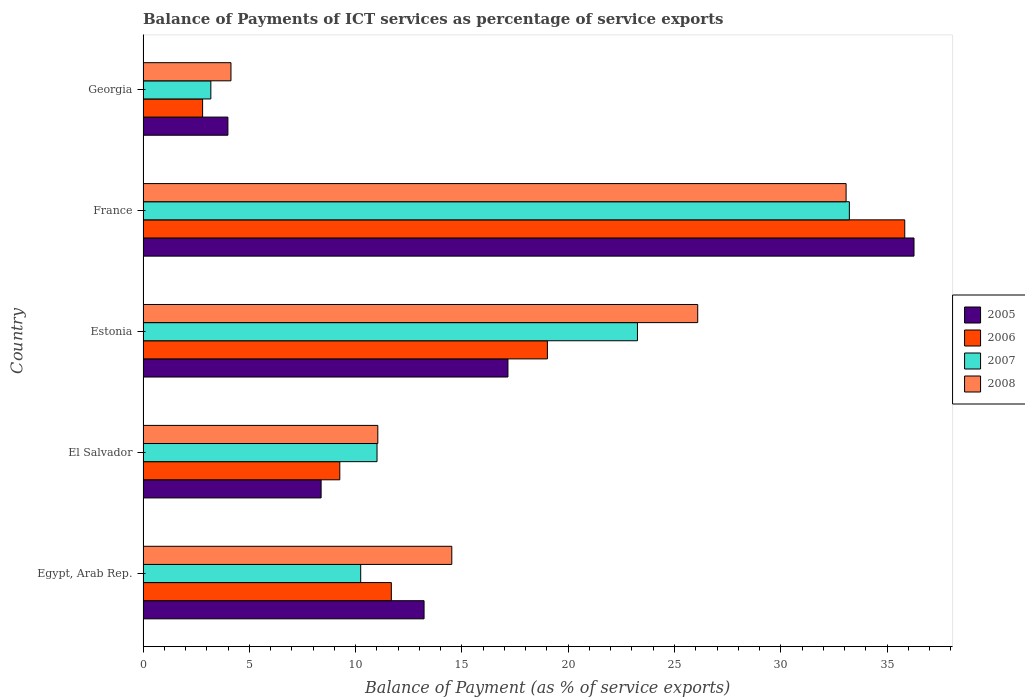Are the number of bars per tick equal to the number of legend labels?
Your answer should be very brief. Yes. How many bars are there on the 2nd tick from the top?
Your answer should be compact. 4. How many bars are there on the 1st tick from the bottom?
Your response must be concise. 4. What is the label of the 3rd group of bars from the top?
Provide a short and direct response. Estonia. In how many cases, is the number of bars for a given country not equal to the number of legend labels?
Your answer should be very brief. 0. What is the balance of payments of ICT services in 2006 in Georgia?
Your answer should be very brief. 2.8. Across all countries, what is the maximum balance of payments of ICT services in 2007?
Provide a succinct answer. 33.23. Across all countries, what is the minimum balance of payments of ICT services in 2008?
Offer a terse response. 4.14. In which country was the balance of payments of ICT services in 2007 minimum?
Keep it short and to the point. Georgia. What is the total balance of payments of ICT services in 2005 in the graph?
Provide a succinct answer. 79.02. What is the difference between the balance of payments of ICT services in 2008 in Egypt, Arab Rep. and that in France?
Ensure brevity in your answer.  -18.55. What is the difference between the balance of payments of ICT services in 2005 in France and the balance of payments of ICT services in 2008 in El Salvador?
Provide a short and direct response. 25.22. What is the average balance of payments of ICT services in 2008 per country?
Your response must be concise. 17.77. What is the difference between the balance of payments of ICT services in 2007 and balance of payments of ICT services in 2006 in Estonia?
Your answer should be compact. 4.24. In how many countries, is the balance of payments of ICT services in 2007 greater than 26 %?
Your answer should be very brief. 1. What is the ratio of the balance of payments of ICT services in 2006 in Estonia to that in France?
Give a very brief answer. 0.53. Is the balance of payments of ICT services in 2008 in Estonia less than that in Georgia?
Offer a terse response. No. What is the difference between the highest and the second highest balance of payments of ICT services in 2007?
Give a very brief answer. 9.97. What is the difference between the highest and the lowest balance of payments of ICT services in 2008?
Keep it short and to the point. 28.94. In how many countries, is the balance of payments of ICT services in 2005 greater than the average balance of payments of ICT services in 2005 taken over all countries?
Your answer should be very brief. 2. What does the 4th bar from the bottom in El Salvador represents?
Give a very brief answer. 2008. Is it the case that in every country, the sum of the balance of payments of ICT services in 2008 and balance of payments of ICT services in 2006 is greater than the balance of payments of ICT services in 2007?
Your response must be concise. Yes. How many bars are there?
Your response must be concise. 20. Are all the bars in the graph horizontal?
Ensure brevity in your answer.  Yes. How many countries are there in the graph?
Keep it short and to the point. 5. What is the difference between two consecutive major ticks on the X-axis?
Give a very brief answer. 5. Does the graph contain any zero values?
Keep it short and to the point. No. Does the graph contain grids?
Keep it short and to the point. No. How many legend labels are there?
Provide a succinct answer. 4. How are the legend labels stacked?
Your response must be concise. Vertical. What is the title of the graph?
Your response must be concise. Balance of Payments of ICT services as percentage of service exports. What is the label or title of the X-axis?
Offer a terse response. Balance of Payment (as % of service exports). What is the label or title of the Y-axis?
Your response must be concise. Country. What is the Balance of Payment (as % of service exports) in 2005 in Egypt, Arab Rep.?
Your response must be concise. 13.22. What is the Balance of Payment (as % of service exports) in 2006 in Egypt, Arab Rep.?
Give a very brief answer. 11.68. What is the Balance of Payment (as % of service exports) in 2007 in Egypt, Arab Rep.?
Your answer should be compact. 10.24. What is the Balance of Payment (as % of service exports) in 2008 in Egypt, Arab Rep.?
Make the answer very short. 14.52. What is the Balance of Payment (as % of service exports) of 2005 in El Salvador?
Provide a succinct answer. 8.38. What is the Balance of Payment (as % of service exports) in 2006 in El Salvador?
Your answer should be compact. 9.25. What is the Balance of Payment (as % of service exports) of 2007 in El Salvador?
Your response must be concise. 11.01. What is the Balance of Payment (as % of service exports) of 2008 in El Salvador?
Make the answer very short. 11.04. What is the Balance of Payment (as % of service exports) of 2005 in Estonia?
Offer a terse response. 17.16. What is the Balance of Payment (as % of service exports) of 2006 in Estonia?
Make the answer very short. 19.02. What is the Balance of Payment (as % of service exports) of 2007 in Estonia?
Your answer should be compact. 23.26. What is the Balance of Payment (as % of service exports) of 2008 in Estonia?
Give a very brief answer. 26.09. What is the Balance of Payment (as % of service exports) in 2005 in France?
Make the answer very short. 36.27. What is the Balance of Payment (as % of service exports) of 2006 in France?
Ensure brevity in your answer.  35.83. What is the Balance of Payment (as % of service exports) in 2007 in France?
Your answer should be compact. 33.23. What is the Balance of Payment (as % of service exports) of 2008 in France?
Your answer should be compact. 33.07. What is the Balance of Payment (as % of service exports) in 2005 in Georgia?
Offer a terse response. 3.99. What is the Balance of Payment (as % of service exports) in 2006 in Georgia?
Your response must be concise. 2.8. What is the Balance of Payment (as % of service exports) in 2007 in Georgia?
Your answer should be very brief. 3.19. What is the Balance of Payment (as % of service exports) of 2008 in Georgia?
Offer a terse response. 4.14. Across all countries, what is the maximum Balance of Payment (as % of service exports) of 2005?
Your answer should be very brief. 36.27. Across all countries, what is the maximum Balance of Payment (as % of service exports) of 2006?
Keep it short and to the point. 35.83. Across all countries, what is the maximum Balance of Payment (as % of service exports) in 2007?
Your response must be concise. 33.23. Across all countries, what is the maximum Balance of Payment (as % of service exports) in 2008?
Provide a short and direct response. 33.07. Across all countries, what is the minimum Balance of Payment (as % of service exports) in 2005?
Make the answer very short. 3.99. Across all countries, what is the minimum Balance of Payment (as % of service exports) of 2006?
Provide a succinct answer. 2.8. Across all countries, what is the minimum Balance of Payment (as % of service exports) in 2007?
Make the answer very short. 3.19. Across all countries, what is the minimum Balance of Payment (as % of service exports) of 2008?
Your response must be concise. 4.14. What is the total Balance of Payment (as % of service exports) of 2005 in the graph?
Your answer should be compact. 79.02. What is the total Balance of Payment (as % of service exports) in 2006 in the graph?
Provide a succinct answer. 78.59. What is the total Balance of Payment (as % of service exports) of 2007 in the graph?
Your response must be concise. 80.92. What is the total Balance of Payment (as % of service exports) of 2008 in the graph?
Offer a very short reply. 88.87. What is the difference between the Balance of Payment (as % of service exports) in 2005 in Egypt, Arab Rep. and that in El Salvador?
Your response must be concise. 4.84. What is the difference between the Balance of Payment (as % of service exports) in 2006 in Egypt, Arab Rep. and that in El Salvador?
Make the answer very short. 2.43. What is the difference between the Balance of Payment (as % of service exports) in 2007 in Egypt, Arab Rep. and that in El Salvador?
Provide a succinct answer. -0.77. What is the difference between the Balance of Payment (as % of service exports) in 2008 in Egypt, Arab Rep. and that in El Salvador?
Your response must be concise. 3.48. What is the difference between the Balance of Payment (as % of service exports) in 2005 in Egypt, Arab Rep. and that in Estonia?
Offer a terse response. -3.95. What is the difference between the Balance of Payment (as % of service exports) of 2006 in Egypt, Arab Rep. and that in Estonia?
Your answer should be very brief. -7.34. What is the difference between the Balance of Payment (as % of service exports) in 2007 in Egypt, Arab Rep. and that in Estonia?
Provide a succinct answer. -13.02. What is the difference between the Balance of Payment (as % of service exports) in 2008 in Egypt, Arab Rep. and that in Estonia?
Keep it short and to the point. -11.57. What is the difference between the Balance of Payment (as % of service exports) in 2005 in Egypt, Arab Rep. and that in France?
Provide a short and direct response. -23.05. What is the difference between the Balance of Payment (as % of service exports) in 2006 in Egypt, Arab Rep. and that in France?
Your answer should be very brief. -24.15. What is the difference between the Balance of Payment (as % of service exports) of 2007 in Egypt, Arab Rep. and that in France?
Your answer should be very brief. -22.99. What is the difference between the Balance of Payment (as % of service exports) in 2008 in Egypt, Arab Rep. and that in France?
Make the answer very short. -18.55. What is the difference between the Balance of Payment (as % of service exports) in 2005 in Egypt, Arab Rep. and that in Georgia?
Keep it short and to the point. 9.23. What is the difference between the Balance of Payment (as % of service exports) of 2006 in Egypt, Arab Rep. and that in Georgia?
Provide a short and direct response. 8.88. What is the difference between the Balance of Payment (as % of service exports) in 2007 in Egypt, Arab Rep. and that in Georgia?
Provide a short and direct response. 7.05. What is the difference between the Balance of Payment (as % of service exports) in 2008 in Egypt, Arab Rep. and that in Georgia?
Make the answer very short. 10.39. What is the difference between the Balance of Payment (as % of service exports) of 2005 in El Salvador and that in Estonia?
Provide a short and direct response. -8.79. What is the difference between the Balance of Payment (as % of service exports) of 2006 in El Salvador and that in Estonia?
Keep it short and to the point. -9.77. What is the difference between the Balance of Payment (as % of service exports) in 2007 in El Salvador and that in Estonia?
Give a very brief answer. -12.25. What is the difference between the Balance of Payment (as % of service exports) in 2008 in El Salvador and that in Estonia?
Your answer should be compact. -15.05. What is the difference between the Balance of Payment (as % of service exports) in 2005 in El Salvador and that in France?
Offer a very short reply. -27.89. What is the difference between the Balance of Payment (as % of service exports) in 2006 in El Salvador and that in France?
Your answer should be compact. -26.58. What is the difference between the Balance of Payment (as % of service exports) of 2007 in El Salvador and that in France?
Your answer should be compact. -22.22. What is the difference between the Balance of Payment (as % of service exports) of 2008 in El Salvador and that in France?
Provide a succinct answer. -22.03. What is the difference between the Balance of Payment (as % of service exports) in 2005 in El Salvador and that in Georgia?
Provide a short and direct response. 4.38. What is the difference between the Balance of Payment (as % of service exports) of 2006 in El Salvador and that in Georgia?
Provide a succinct answer. 6.45. What is the difference between the Balance of Payment (as % of service exports) in 2007 in El Salvador and that in Georgia?
Make the answer very short. 7.82. What is the difference between the Balance of Payment (as % of service exports) in 2008 in El Salvador and that in Georgia?
Make the answer very short. 6.91. What is the difference between the Balance of Payment (as % of service exports) in 2005 in Estonia and that in France?
Offer a very short reply. -19.1. What is the difference between the Balance of Payment (as % of service exports) of 2006 in Estonia and that in France?
Ensure brevity in your answer.  -16.81. What is the difference between the Balance of Payment (as % of service exports) in 2007 in Estonia and that in France?
Provide a short and direct response. -9.97. What is the difference between the Balance of Payment (as % of service exports) in 2008 in Estonia and that in France?
Provide a short and direct response. -6.98. What is the difference between the Balance of Payment (as % of service exports) in 2005 in Estonia and that in Georgia?
Offer a very short reply. 13.17. What is the difference between the Balance of Payment (as % of service exports) of 2006 in Estonia and that in Georgia?
Offer a very short reply. 16.22. What is the difference between the Balance of Payment (as % of service exports) of 2007 in Estonia and that in Georgia?
Make the answer very short. 20.07. What is the difference between the Balance of Payment (as % of service exports) of 2008 in Estonia and that in Georgia?
Your answer should be very brief. 21.96. What is the difference between the Balance of Payment (as % of service exports) in 2005 in France and that in Georgia?
Your answer should be compact. 32.28. What is the difference between the Balance of Payment (as % of service exports) of 2006 in France and that in Georgia?
Provide a succinct answer. 33.03. What is the difference between the Balance of Payment (as % of service exports) in 2007 in France and that in Georgia?
Keep it short and to the point. 30.04. What is the difference between the Balance of Payment (as % of service exports) of 2008 in France and that in Georgia?
Ensure brevity in your answer.  28.94. What is the difference between the Balance of Payment (as % of service exports) of 2005 in Egypt, Arab Rep. and the Balance of Payment (as % of service exports) of 2006 in El Salvador?
Keep it short and to the point. 3.96. What is the difference between the Balance of Payment (as % of service exports) of 2005 in Egypt, Arab Rep. and the Balance of Payment (as % of service exports) of 2007 in El Salvador?
Give a very brief answer. 2.21. What is the difference between the Balance of Payment (as % of service exports) of 2005 in Egypt, Arab Rep. and the Balance of Payment (as % of service exports) of 2008 in El Salvador?
Your response must be concise. 2.18. What is the difference between the Balance of Payment (as % of service exports) in 2006 in Egypt, Arab Rep. and the Balance of Payment (as % of service exports) in 2007 in El Salvador?
Offer a very short reply. 0.67. What is the difference between the Balance of Payment (as % of service exports) in 2006 in Egypt, Arab Rep. and the Balance of Payment (as % of service exports) in 2008 in El Salvador?
Your response must be concise. 0.64. What is the difference between the Balance of Payment (as % of service exports) in 2007 in Egypt, Arab Rep. and the Balance of Payment (as % of service exports) in 2008 in El Salvador?
Your answer should be very brief. -0.8. What is the difference between the Balance of Payment (as % of service exports) of 2005 in Egypt, Arab Rep. and the Balance of Payment (as % of service exports) of 2006 in Estonia?
Your answer should be compact. -5.8. What is the difference between the Balance of Payment (as % of service exports) of 2005 in Egypt, Arab Rep. and the Balance of Payment (as % of service exports) of 2007 in Estonia?
Your answer should be very brief. -10.04. What is the difference between the Balance of Payment (as % of service exports) in 2005 in Egypt, Arab Rep. and the Balance of Payment (as % of service exports) in 2008 in Estonia?
Provide a short and direct response. -12.87. What is the difference between the Balance of Payment (as % of service exports) in 2006 in Egypt, Arab Rep. and the Balance of Payment (as % of service exports) in 2007 in Estonia?
Give a very brief answer. -11.58. What is the difference between the Balance of Payment (as % of service exports) of 2006 in Egypt, Arab Rep. and the Balance of Payment (as % of service exports) of 2008 in Estonia?
Your answer should be very brief. -14.41. What is the difference between the Balance of Payment (as % of service exports) in 2007 in Egypt, Arab Rep. and the Balance of Payment (as % of service exports) in 2008 in Estonia?
Your answer should be very brief. -15.85. What is the difference between the Balance of Payment (as % of service exports) of 2005 in Egypt, Arab Rep. and the Balance of Payment (as % of service exports) of 2006 in France?
Offer a terse response. -22.61. What is the difference between the Balance of Payment (as % of service exports) in 2005 in Egypt, Arab Rep. and the Balance of Payment (as % of service exports) in 2007 in France?
Your response must be concise. -20.01. What is the difference between the Balance of Payment (as % of service exports) of 2005 in Egypt, Arab Rep. and the Balance of Payment (as % of service exports) of 2008 in France?
Ensure brevity in your answer.  -19.85. What is the difference between the Balance of Payment (as % of service exports) of 2006 in Egypt, Arab Rep. and the Balance of Payment (as % of service exports) of 2007 in France?
Your answer should be very brief. -21.55. What is the difference between the Balance of Payment (as % of service exports) in 2006 in Egypt, Arab Rep. and the Balance of Payment (as % of service exports) in 2008 in France?
Offer a very short reply. -21.39. What is the difference between the Balance of Payment (as % of service exports) in 2007 in Egypt, Arab Rep. and the Balance of Payment (as % of service exports) in 2008 in France?
Provide a short and direct response. -22.83. What is the difference between the Balance of Payment (as % of service exports) in 2005 in Egypt, Arab Rep. and the Balance of Payment (as % of service exports) in 2006 in Georgia?
Keep it short and to the point. 10.42. What is the difference between the Balance of Payment (as % of service exports) of 2005 in Egypt, Arab Rep. and the Balance of Payment (as % of service exports) of 2007 in Georgia?
Your answer should be very brief. 10.03. What is the difference between the Balance of Payment (as % of service exports) in 2005 in Egypt, Arab Rep. and the Balance of Payment (as % of service exports) in 2008 in Georgia?
Your answer should be very brief. 9.08. What is the difference between the Balance of Payment (as % of service exports) of 2006 in Egypt, Arab Rep. and the Balance of Payment (as % of service exports) of 2007 in Georgia?
Ensure brevity in your answer.  8.49. What is the difference between the Balance of Payment (as % of service exports) in 2006 in Egypt, Arab Rep. and the Balance of Payment (as % of service exports) in 2008 in Georgia?
Offer a very short reply. 7.54. What is the difference between the Balance of Payment (as % of service exports) in 2007 in Egypt, Arab Rep. and the Balance of Payment (as % of service exports) in 2008 in Georgia?
Give a very brief answer. 6.1. What is the difference between the Balance of Payment (as % of service exports) of 2005 in El Salvador and the Balance of Payment (as % of service exports) of 2006 in Estonia?
Your answer should be compact. -10.65. What is the difference between the Balance of Payment (as % of service exports) of 2005 in El Salvador and the Balance of Payment (as % of service exports) of 2007 in Estonia?
Give a very brief answer. -14.88. What is the difference between the Balance of Payment (as % of service exports) of 2005 in El Salvador and the Balance of Payment (as % of service exports) of 2008 in Estonia?
Your response must be concise. -17.72. What is the difference between the Balance of Payment (as % of service exports) in 2006 in El Salvador and the Balance of Payment (as % of service exports) in 2007 in Estonia?
Keep it short and to the point. -14. What is the difference between the Balance of Payment (as % of service exports) of 2006 in El Salvador and the Balance of Payment (as % of service exports) of 2008 in Estonia?
Ensure brevity in your answer.  -16.84. What is the difference between the Balance of Payment (as % of service exports) of 2007 in El Salvador and the Balance of Payment (as % of service exports) of 2008 in Estonia?
Your answer should be compact. -15.09. What is the difference between the Balance of Payment (as % of service exports) in 2005 in El Salvador and the Balance of Payment (as % of service exports) in 2006 in France?
Your response must be concise. -27.46. What is the difference between the Balance of Payment (as % of service exports) in 2005 in El Salvador and the Balance of Payment (as % of service exports) in 2007 in France?
Your answer should be very brief. -24.85. What is the difference between the Balance of Payment (as % of service exports) in 2005 in El Salvador and the Balance of Payment (as % of service exports) in 2008 in France?
Make the answer very short. -24.7. What is the difference between the Balance of Payment (as % of service exports) of 2006 in El Salvador and the Balance of Payment (as % of service exports) of 2007 in France?
Keep it short and to the point. -23.97. What is the difference between the Balance of Payment (as % of service exports) in 2006 in El Salvador and the Balance of Payment (as % of service exports) in 2008 in France?
Ensure brevity in your answer.  -23.82. What is the difference between the Balance of Payment (as % of service exports) in 2007 in El Salvador and the Balance of Payment (as % of service exports) in 2008 in France?
Give a very brief answer. -22.07. What is the difference between the Balance of Payment (as % of service exports) in 2005 in El Salvador and the Balance of Payment (as % of service exports) in 2006 in Georgia?
Offer a terse response. 5.57. What is the difference between the Balance of Payment (as % of service exports) in 2005 in El Salvador and the Balance of Payment (as % of service exports) in 2007 in Georgia?
Your answer should be very brief. 5.19. What is the difference between the Balance of Payment (as % of service exports) of 2005 in El Salvador and the Balance of Payment (as % of service exports) of 2008 in Georgia?
Keep it short and to the point. 4.24. What is the difference between the Balance of Payment (as % of service exports) of 2006 in El Salvador and the Balance of Payment (as % of service exports) of 2007 in Georgia?
Ensure brevity in your answer.  6.07. What is the difference between the Balance of Payment (as % of service exports) of 2006 in El Salvador and the Balance of Payment (as % of service exports) of 2008 in Georgia?
Offer a very short reply. 5.12. What is the difference between the Balance of Payment (as % of service exports) of 2007 in El Salvador and the Balance of Payment (as % of service exports) of 2008 in Georgia?
Provide a succinct answer. 6.87. What is the difference between the Balance of Payment (as % of service exports) of 2005 in Estonia and the Balance of Payment (as % of service exports) of 2006 in France?
Keep it short and to the point. -18.67. What is the difference between the Balance of Payment (as % of service exports) in 2005 in Estonia and the Balance of Payment (as % of service exports) in 2007 in France?
Keep it short and to the point. -16.06. What is the difference between the Balance of Payment (as % of service exports) in 2005 in Estonia and the Balance of Payment (as % of service exports) in 2008 in France?
Give a very brief answer. -15.91. What is the difference between the Balance of Payment (as % of service exports) in 2006 in Estonia and the Balance of Payment (as % of service exports) in 2007 in France?
Ensure brevity in your answer.  -14.21. What is the difference between the Balance of Payment (as % of service exports) in 2006 in Estonia and the Balance of Payment (as % of service exports) in 2008 in France?
Give a very brief answer. -14.05. What is the difference between the Balance of Payment (as % of service exports) in 2007 in Estonia and the Balance of Payment (as % of service exports) in 2008 in France?
Keep it short and to the point. -9.82. What is the difference between the Balance of Payment (as % of service exports) in 2005 in Estonia and the Balance of Payment (as % of service exports) in 2006 in Georgia?
Your answer should be compact. 14.36. What is the difference between the Balance of Payment (as % of service exports) of 2005 in Estonia and the Balance of Payment (as % of service exports) of 2007 in Georgia?
Give a very brief answer. 13.98. What is the difference between the Balance of Payment (as % of service exports) in 2005 in Estonia and the Balance of Payment (as % of service exports) in 2008 in Georgia?
Your answer should be compact. 13.03. What is the difference between the Balance of Payment (as % of service exports) of 2006 in Estonia and the Balance of Payment (as % of service exports) of 2007 in Georgia?
Give a very brief answer. 15.83. What is the difference between the Balance of Payment (as % of service exports) in 2006 in Estonia and the Balance of Payment (as % of service exports) in 2008 in Georgia?
Keep it short and to the point. 14.89. What is the difference between the Balance of Payment (as % of service exports) of 2007 in Estonia and the Balance of Payment (as % of service exports) of 2008 in Georgia?
Make the answer very short. 19.12. What is the difference between the Balance of Payment (as % of service exports) of 2005 in France and the Balance of Payment (as % of service exports) of 2006 in Georgia?
Your answer should be very brief. 33.47. What is the difference between the Balance of Payment (as % of service exports) in 2005 in France and the Balance of Payment (as % of service exports) in 2007 in Georgia?
Your answer should be compact. 33.08. What is the difference between the Balance of Payment (as % of service exports) in 2005 in France and the Balance of Payment (as % of service exports) in 2008 in Georgia?
Ensure brevity in your answer.  32.13. What is the difference between the Balance of Payment (as % of service exports) of 2006 in France and the Balance of Payment (as % of service exports) of 2007 in Georgia?
Make the answer very short. 32.64. What is the difference between the Balance of Payment (as % of service exports) in 2006 in France and the Balance of Payment (as % of service exports) in 2008 in Georgia?
Keep it short and to the point. 31.7. What is the difference between the Balance of Payment (as % of service exports) in 2007 in France and the Balance of Payment (as % of service exports) in 2008 in Georgia?
Offer a very short reply. 29.09. What is the average Balance of Payment (as % of service exports) of 2005 per country?
Give a very brief answer. 15.8. What is the average Balance of Payment (as % of service exports) of 2006 per country?
Offer a very short reply. 15.72. What is the average Balance of Payment (as % of service exports) of 2007 per country?
Offer a terse response. 16.18. What is the average Balance of Payment (as % of service exports) in 2008 per country?
Your response must be concise. 17.77. What is the difference between the Balance of Payment (as % of service exports) in 2005 and Balance of Payment (as % of service exports) in 2006 in Egypt, Arab Rep.?
Give a very brief answer. 1.54. What is the difference between the Balance of Payment (as % of service exports) of 2005 and Balance of Payment (as % of service exports) of 2007 in Egypt, Arab Rep.?
Give a very brief answer. 2.98. What is the difference between the Balance of Payment (as % of service exports) of 2005 and Balance of Payment (as % of service exports) of 2008 in Egypt, Arab Rep.?
Make the answer very short. -1.3. What is the difference between the Balance of Payment (as % of service exports) in 2006 and Balance of Payment (as % of service exports) in 2007 in Egypt, Arab Rep.?
Keep it short and to the point. 1.44. What is the difference between the Balance of Payment (as % of service exports) of 2006 and Balance of Payment (as % of service exports) of 2008 in Egypt, Arab Rep.?
Your answer should be compact. -2.84. What is the difference between the Balance of Payment (as % of service exports) in 2007 and Balance of Payment (as % of service exports) in 2008 in Egypt, Arab Rep.?
Your answer should be very brief. -4.29. What is the difference between the Balance of Payment (as % of service exports) of 2005 and Balance of Payment (as % of service exports) of 2006 in El Salvador?
Offer a very short reply. -0.88. What is the difference between the Balance of Payment (as % of service exports) of 2005 and Balance of Payment (as % of service exports) of 2007 in El Salvador?
Your response must be concise. -2.63. What is the difference between the Balance of Payment (as % of service exports) of 2005 and Balance of Payment (as % of service exports) of 2008 in El Salvador?
Offer a terse response. -2.67. What is the difference between the Balance of Payment (as % of service exports) of 2006 and Balance of Payment (as % of service exports) of 2007 in El Salvador?
Offer a terse response. -1.75. What is the difference between the Balance of Payment (as % of service exports) in 2006 and Balance of Payment (as % of service exports) in 2008 in El Salvador?
Ensure brevity in your answer.  -1.79. What is the difference between the Balance of Payment (as % of service exports) of 2007 and Balance of Payment (as % of service exports) of 2008 in El Salvador?
Provide a short and direct response. -0.04. What is the difference between the Balance of Payment (as % of service exports) in 2005 and Balance of Payment (as % of service exports) in 2006 in Estonia?
Make the answer very short. -1.86. What is the difference between the Balance of Payment (as % of service exports) in 2005 and Balance of Payment (as % of service exports) in 2007 in Estonia?
Your response must be concise. -6.09. What is the difference between the Balance of Payment (as % of service exports) of 2005 and Balance of Payment (as % of service exports) of 2008 in Estonia?
Give a very brief answer. -8.93. What is the difference between the Balance of Payment (as % of service exports) in 2006 and Balance of Payment (as % of service exports) in 2007 in Estonia?
Provide a succinct answer. -4.24. What is the difference between the Balance of Payment (as % of service exports) of 2006 and Balance of Payment (as % of service exports) of 2008 in Estonia?
Ensure brevity in your answer.  -7.07. What is the difference between the Balance of Payment (as % of service exports) in 2007 and Balance of Payment (as % of service exports) in 2008 in Estonia?
Your answer should be compact. -2.84. What is the difference between the Balance of Payment (as % of service exports) in 2005 and Balance of Payment (as % of service exports) in 2006 in France?
Offer a terse response. 0.44. What is the difference between the Balance of Payment (as % of service exports) of 2005 and Balance of Payment (as % of service exports) of 2007 in France?
Keep it short and to the point. 3.04. What is the difference between the Balance of Payment (as % of service exports) of 2005 and Balance of Payment (as % of service exports) of 2008 in France?
Your answer should be compact. 3.19. What is the difference between the Balance of Payment (as % of service exports) in 2006 and Balance of Payment (as % of service exports) in 2007 in France?
Offer a terse response. 2.61. What is the difference between the Balance of Payment (as % of service exports) of 2006 and Balance of Payment (as % of service exports) of 2008 in France?
Make the answer very short. 2.76. What is the difference between the Balance of Payment (as % of service exports) in 2007 and Balance of Payment (as % of service exports) in 2008 in France?
Make the answer very short. 0.15. What is the difference between the Balance of Payment (as % of service exports) of 2005 and Balance of Payment (as % of service exports) of 2006 in Georgia?
Provide a succinct answer. 1.19. What is the difference between the Balance of Payment (as % of service exports) of 2005 and Balance of Payment (as % of service exports) of 2007 in Georgia?
Provide a short and direct response. 0.8. What is the difference between the Balance of Payment (as % of service exports) of 2005 and Balance of Payment (as % of service exports) of 2008 in Georgia?
Keep it short and to the point. -0.14. What is the difference between the Balance of Payment (as % of service exports) of 2006 and Balance of Payment (as % of service exports) of 2007 in Georgia?
Keep it short and to the point. -0.39. What is the difference between the Balance of Payment (as % of service exports) of 2006 and Balance of Payment (as % of service exports) of 2008 in Georgia?
Provide a succinct answer. -1.33. What is the difference between the Balance of Payment (as % of service exports) in 2007 and Balance of Payment (as % of service exports) in 2008 in Georgia?
Give a very brief answer. -0.95. What is the ratio of the Balance of Payment (as % of service exports) of 2005 in Egypt, Arab Rep. to that in El Salvador?
Give a very brief answer. 1.58. What is the ratio of the Balance of Payment (as % of service exports) in 2006 in Egypt, Arab Rep. to that in El Salvador?
Your answer should be very brief. 1.26. What is the ratio of the Balance of Payment (as % of service exports) in 2007 in Egypt, Arab Rep. to that in El Salvador?
Offer a terse response. 0.93. What is the ratio of the Balance of Payment (as % of service exports) in 2008 in Egypt, Arab Rep. to that in El Salvador?
Your answer should be compact. 1.32. What is the ratio of the Balance of Payment (as % of service exports) of 2005 in Egypt, Arab Rep. to that in Estonia?
Offer a very short reply. 0.77. What is the ratio of the Balance of Payment (as % of service exports) in 2006 in Egypt, Arab Rep. to that in Estonia?
Provide a succinct answer. 0.61. What is the ratio of the Balance of Payment (as % of service exports) in 2007 in Egypt, Arab Rep. to that in Estonia?
Offer a very short reply. 0.44. What is the ratio of the Balance of Payment (as % of service exports) of 2008 in Egypt, Arab Rep. to that in Estonia?
Provide a succinct answer. 0.56. What is the ratio of the Balance of Payment (as % of service exports) in 2005 in Egypt, Arab Rep. to that in France?
Keep it short and to the point. 0.36. What is the ratio of the Balance of Payment (as % of service exports) of 2006 in Egypt, Arab Rep. to that in France?
Offer a terse response. 0.33. What is the ratio of the Balance of Payment (as % of service exports) in 2007 in Egypt, Arab Rep. to that in France?
Ensure brevity in your answer.  0.31. What is the ratio of the Balance of Payment (as % of service exports) in 2008 in Egypt, Arab Rep. to that in France?
Provide a succinct answer. 0.44. What is the ratio of the Balance of Payment (as % of service exports) in 2005 in Egypt, Arab Rep. to that in Georgia?
Provide a succinct answer. 3.31. What is the ratio of the Balance of Payment (as % of service exports) of 2006 in Egypt, Arab Rep. to that in Georgia?
Make the answer very short. 4.17. What is the ratio of the Balance of Payment (as % of service exports) of 2007 in Egypt, Arab Rep. to that in Georgia?
Give a very brief answer. 3.21. What is the ratio of the Balance of Payment (as % of service exports) of 2008 in Egypt, Arab Rep. to that in Georgia?
Give a very brief answer. 3.51. What is the ratio of the Balance of Payment (as % of service exports) of 2005 in El Salvador to that in Estonia?
Make the answer very short. 0.49. What is the ratio of the Balance of Payment (as % of service exports) of 2006 in El Salvador to that in Estonia?
Offer a very short reply. 0.49. What is the ratio of the Balance of Payment (as % of service exports) in 2007 in El Salvador to that in Estonia?
Your response must be concise. 0.47. What is the ratio of the Balance of Payment (as % of service exports) in 2008 in El Salvador to that in Estonia?
Offer a very short reply. 0.42. What is the ratio of the Balance of Payment (as % of service exports) in 2005 in El Salvador to that in France?
Your response must be concise. 0.23. What is the ratio of the Balance of Payment (as % of service exports) in 2006 in El Salvador to that in France?
Ensure brevity in your answer.  0.26. What is the ratio of the Balance of Payment (as % of service exports) in 2007 in El Salvador to that in France?
Your answer should be very brief. 0.33. What is the ratio of the Balance of Payment (as % of service exports) of 2008 in El Salvador to that in France?
Ensure brevity in your answer.  0.33. What is the ratio of the Balance of Payment (as % of service exports) of 2005 in El Salvador to that in Georgia?
Give a very brief answer. 2.1. What is the ratio of the Balance of Payment (as % of service exports) of 2006 in El Salvador to that in Georgia?
Your answer should be compact. 3.3. What is the ratio of the Balance of Payment (as % of service exports) of 2007 in El Salvador to that in Georgia?
Provide a short and direct response. 3.45. What is the ratio of the Balance of Payment (as % of service exports) in 2008 in El Salvador to that in Georgia?
Give a very brief answer. 2.67. What is the ratio of the Balance of Payment (as % of service exports) of 2005 in Estonia to that in France?
Provide a short and direct response. 0.47. What is the ratio of the Balance of Payment (as % of service exports) of 2006 in Estonia to that in France?
Keep it short and to the point. 0.53. What is the ratio of the Balance of Payment (as % of service exports) of 2007 in Estonia to that in France?
Provide a succinct answer. 0.7. What is the ratio of the Balance of Payment (as % of service exports) of 2008 in Estonia to that in France?
Make the answer very short. 0.79. What is the ratio of the Balance of Payment (as % of service exports) in 2005 in Estonia to that in Georgia?
Provide a succinct answer. 4.3. What is the ratio of the Balance of Payment (as % of service exports) in 2006 in Estonia to that in Georgia?
Offer a very short reply. 6.79. What is the ratio of the Balance of Payment (as % of service exports) in 2007 in Estonia to that in Georgia?
Offer a terse response. 7.29. What is the ratio of the Balance of Payment (as % of service exports) of 2008 in Estonia to that in Georgia?
Give a very brief answer. 6.31. What is the ratio of the Balance of Payment (as % of service exports) of 2005 in France to that in Georgia?
Your response must be concise. 9.09. What is the ratio of the Balance of Payment (as % of service exports) in 2006 in France to that in Georgia?
Give a very brief answer. 12.79. What is the ratio of the Balance of Payment (as % of service exports) in 2007 in France to that in Georgia?
Make the answer very short. 10.42. What is the ratio of the Balance of Payment (as % of service exports) of 2008 in France to that in Georgia?
Provide a short and direct response. 8. What is the difference between the highest and the second highest Balance of Payment (as % of service exports) in 2005?
Ensure brevity in your answer.  19.1. What is the difference between the highest and the second highest Balance of Payment (as % of service exports) of 2006?
Provide a succinct answer. 16.81. What is the difference between the highest and the second highest Balance of Payment (as % of service exports) of 2007?
Make the answer very short. 9.97. What is the difference between the highest and the second highest Balance of Payment (as % of service exports) in 2008?
Provide a short and direct response. 6.98. What is the difference between the highest and the lowest Balance of Payment (as % of service exports) of 2005?
Keep it short and to the point. 32.28. What is the difference between the highest and the lowest Balance of Payment (as % of service exports) in 2006?
Your response must be concise. 33.03. What is the difference between the highest and the lowest Balance of Payment (as % of service exports) in 2007?
Your response must be concise. 30.04. What is the difference between the highest and the lowest Balance of Payment (as % of service exports) of 2008?
Ensure brevity in your answer.  28.94. 